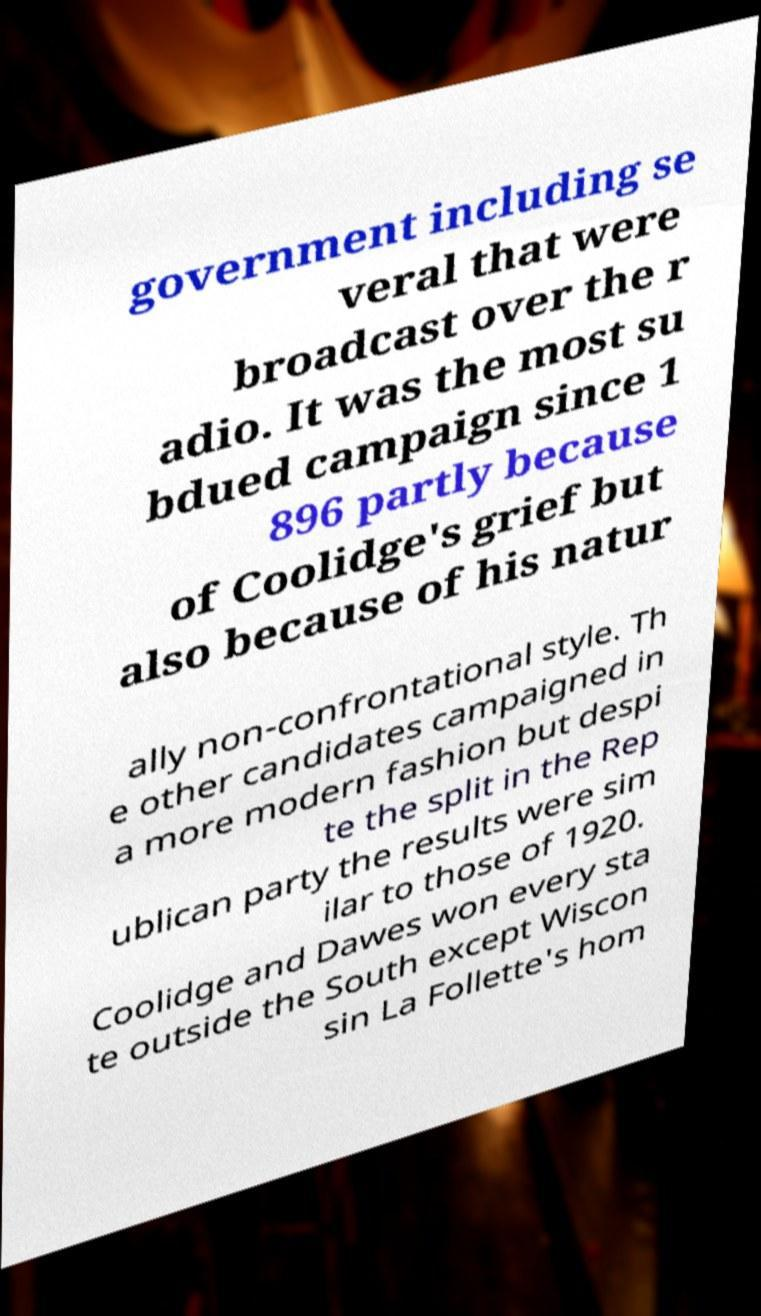What messages or text are displayed in this image? I need them in a readable, typed format. government including se veral that were broadcast over the r adio. It was the most su bdued campaign since 1 896 partly because of Coolidge's grief but also because of his natur ally non-confrontational style. Th e other candidates campaigned in a more modern fashion but despi te the split in the Rep ublican party the results were sim ilar to those of 1920. Coolidge and Dawes won every sta te outside the South except Wiscon sin La Follette's hom 